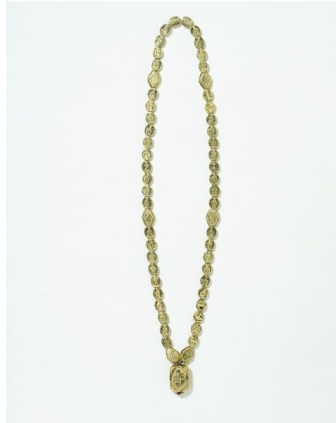Can you describe the overall aesthetic of the necklace? The overall aesthetic of the necklace is one of classic elegance. The uniform golden hue of the beads creates a harmonious and luxurious appearance, while the finely crafted pendant adds a touch of intricate artistry. The smooth, reflective surface of the beads contrasts beautifully with the detailed floral pattern on the pendant, making the piece both eye-catching and refined. This necklace would likely appeal to someone with an appreciation for timeless jewelry designs. Where do you think this necklace would be appropriate to wear? This necklace would be a perfect accessory for formal events such as weddings, galas, or cocktail parties where elegant attire is essential. Its sophisticated design also makes it suitable for professional settings like business dinners or conferences where one wants to make a refined statement. Additionally, it could complement an elegant evening dress for a night out at a high-end restaurant or theater. If this necklace had a story, what would it be? Once upon a time, in a quaint village nestled between rolling hills and flourishing meadows, there was a master jeweler renowned for his exceptional craftsmanship. He was commissioned by a noblewoman to create a necklace that would symbolize her enduring love. With meticulous care, he selected the finest gold beads and etched a flower into a grand pendant, representing the blossoming of her affection. The noblewoman wore the necklace on the night of a grand ball, where she was reunited with her long-lost lover, who had returned from faraway lands. The necklace became a treasured heirloom, passed down through generations, each bead and etching capturing the essence of timeless love and unity. 